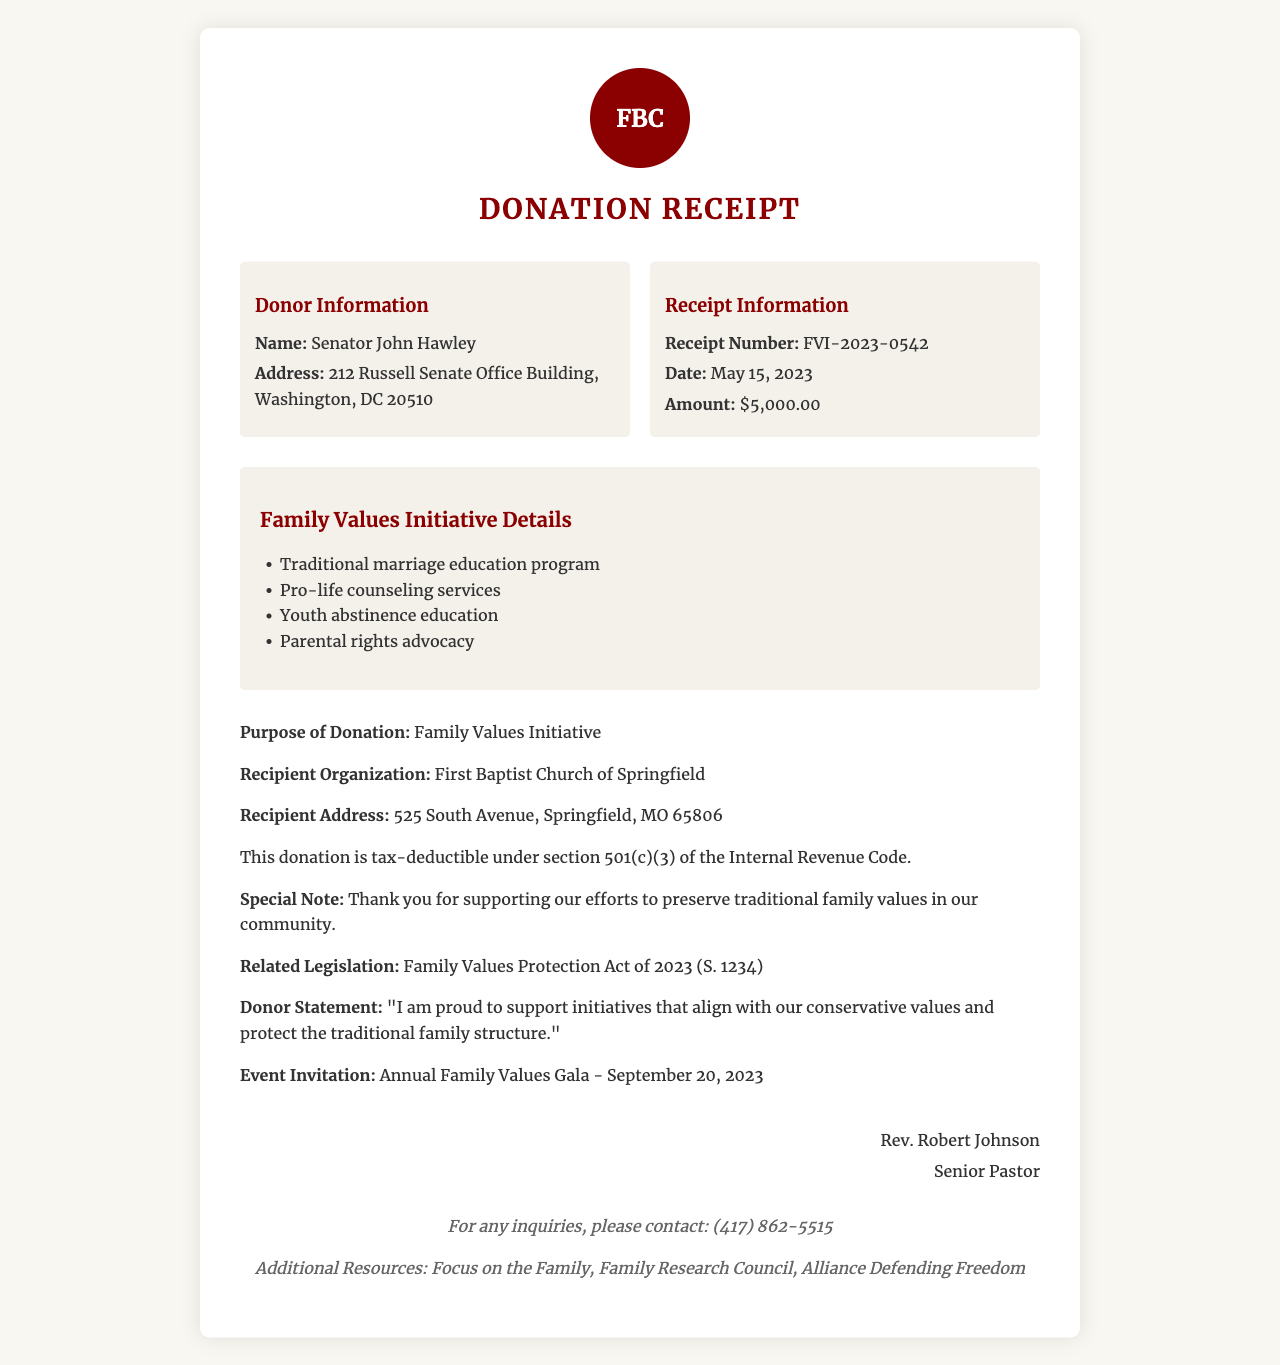What is the donation amount? The donation amount is specified in the document as $5,000.00.
Answer: $5,000.00 Who is the authorized signatory? The authorized signatory is listed in the receipt as Rev. Robert Johnson.
Answer: Rev. Robert Johnson What is the date of the donation? The date of the donation is mentioned as May 15, 2023.
Answer: May 15, 2023 What initiative is supported by the donation? The purpose for the donation is indicated as the Family Values Initiative.
Answer: Family Values Initiative What is the recipient organization? The receipt states that the recipient organization is First Baptist Church of Springfield.
Answer: First Baptist Church of Springfield How does the donation align with Republican values? The donor statement reflects support for initiatives that protect traditional family structures, indicating alignment with Republican values.
Answer: Protect traditional family structure What is the related legislation mentioned? The document specifies the related legislation as the Family Values Protection Act of 2023 (S. 1234).
Answer: Family Values Protection Act of 2023 (S. 1234) What event is the donor invited to? An invitation to the Annual Family Values Gala on September 20, 2023 is included in the document.
Answer: Annual Family Values Gala - September 20, 2023 What is the purpose of the donation? The purpose of the donation is outlined in the document as supporting the Family Values Initiative.
Answer: Family Values Initiative 